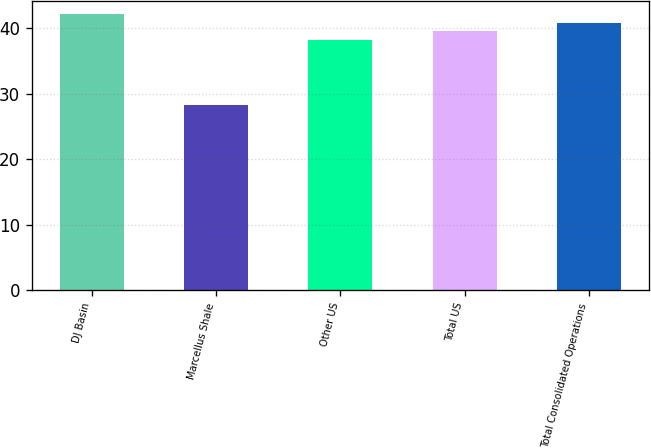Convert chart. <chart><loc_0><loc_0><loc_500><loc_500><bar_chart><fcel>DJ Basin<fcel>Marcellus Shale<fcel>Other US<fcel>Total US<fcel>Total Consolidated Operations<nl><fcel>42.11<fcel>28.25<fcel>38.26<fcel>39.59<fcel>40.85<nl></chart> 